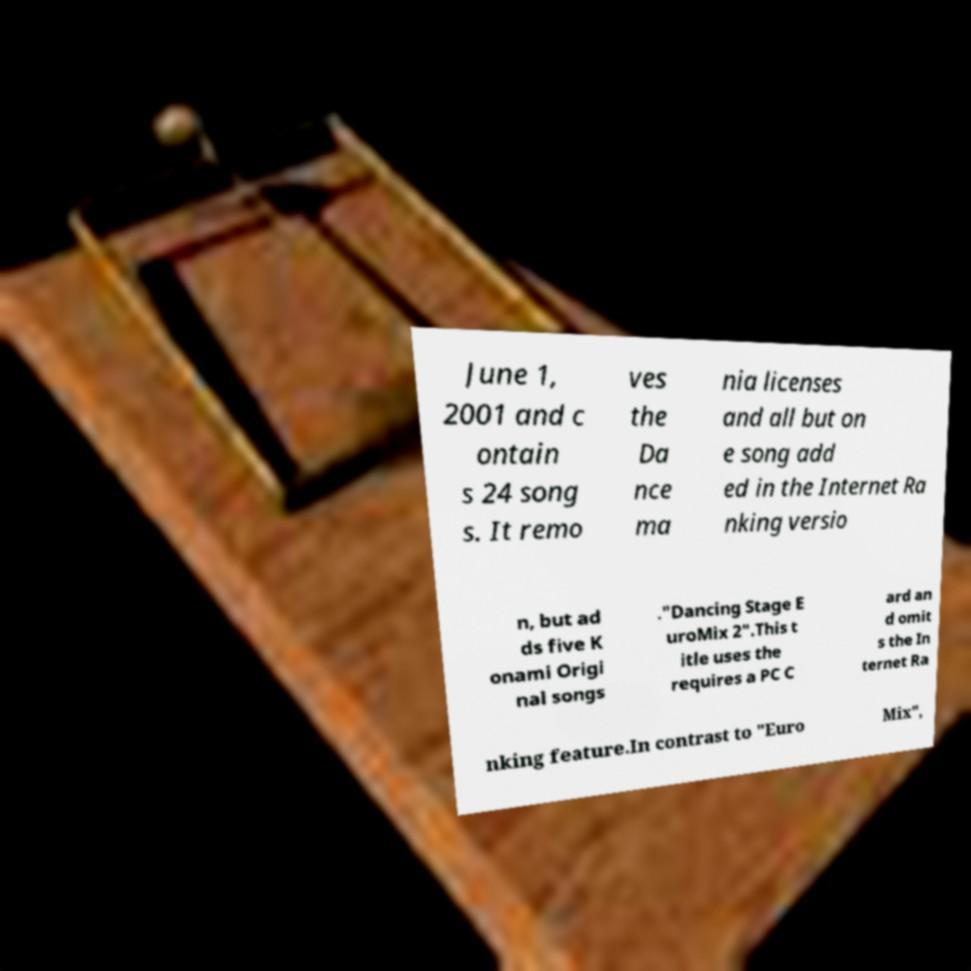Could you assist in decoding the text presented in this image and type it out clearly? June 1, 2001 and c ontain s 24 song s. It remo ves the Da nce ma nia licenses and all but on e song add ed in the Internet Ra nking versio n, but ad ds five K onami Origi nal songs ."Dancing Stage E uroMix 2".This t itle uses the requires a PC C ard an d omit s the In ternet Ra nking feature.In contrast to "Euro Mix", 